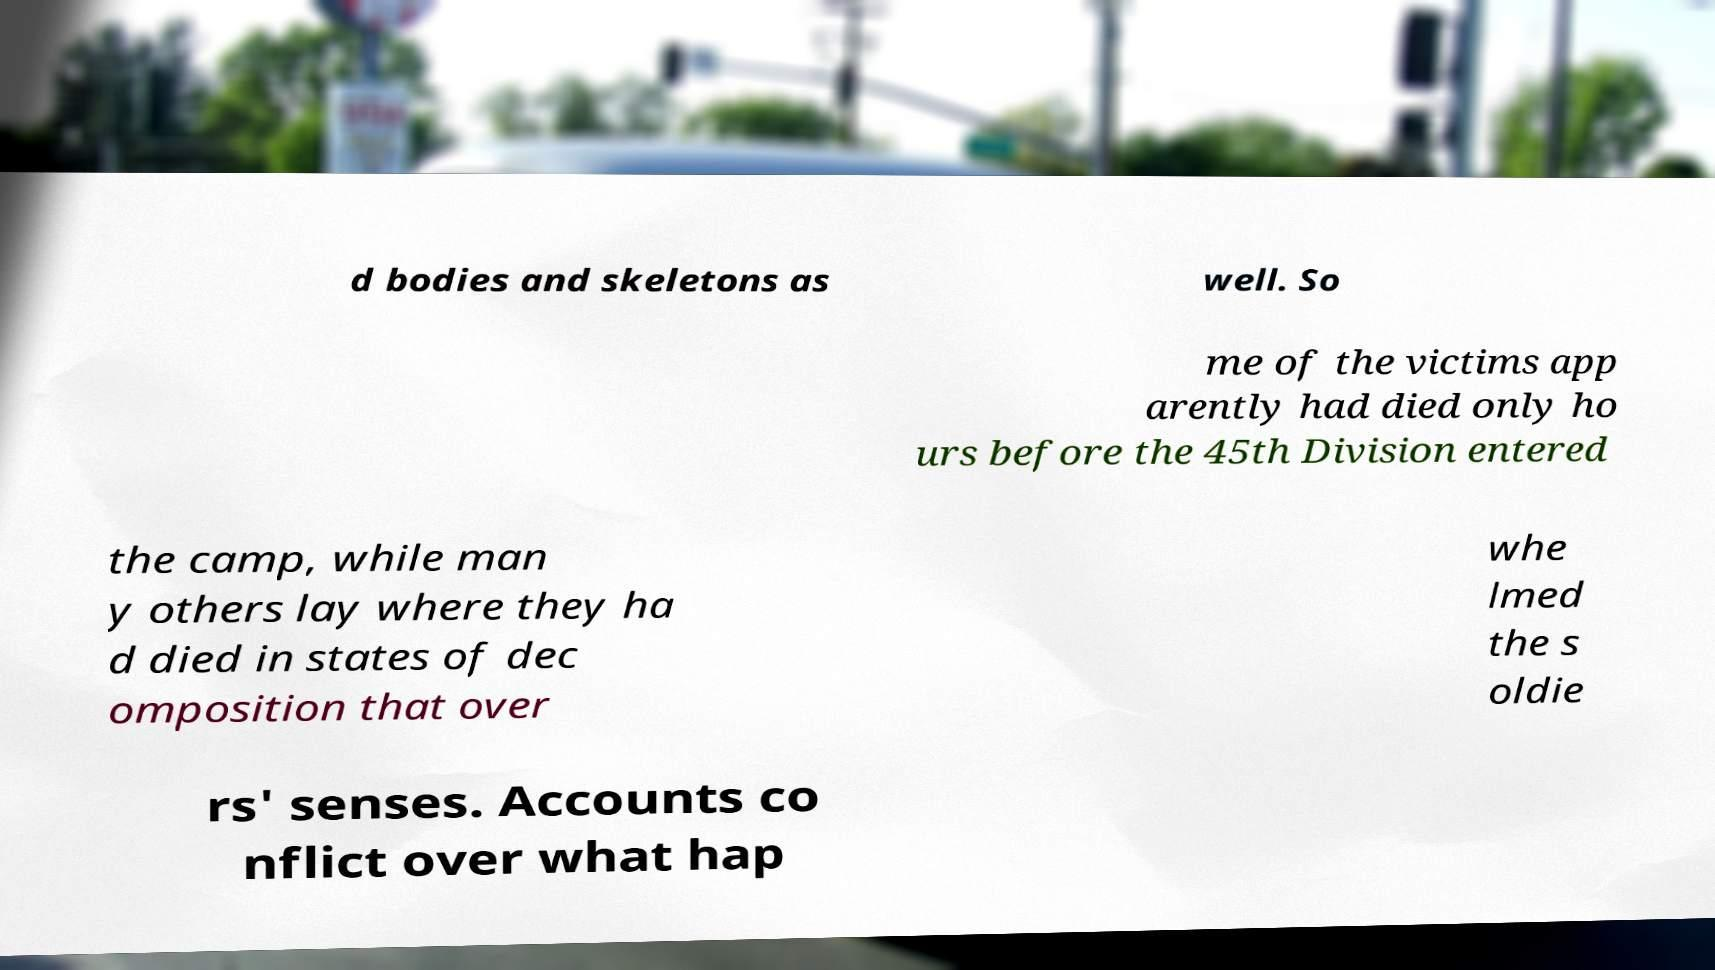For documentation purposes, I need the text within this image transcribed. Could you provide that? d bodies and skeletons as well. So me of the victims app arently had died only ho urs before the 45th Division entered the camp, while man y others lay where they ha d died in states of dec omposition that over whe lmed the s oldie rs' senses. Accounts co nflict over what hap 